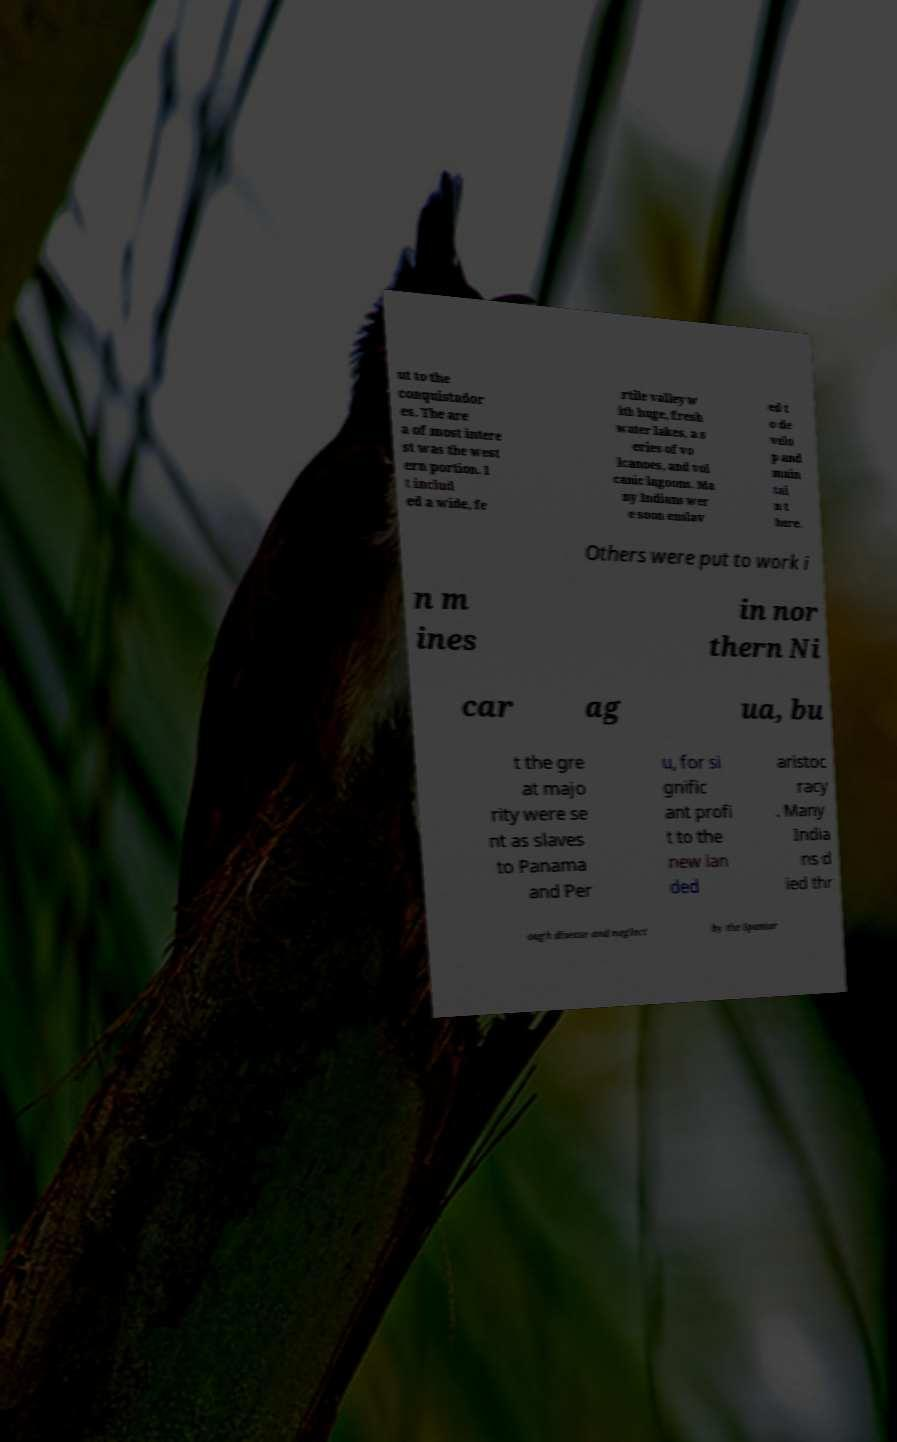Please read and relay the text visible in this image. What does it say? ut to the conquistador es. The are a of most intere st was the west ern portion. I t includ ed a wide, fe rtile valley w ith huge, fresh water lakes, a s eries of vo lcanoes, and vol canic lagoons. Ma ny Indians wer e soon enslav ed t o de velo p and main tai n t here. Others were put to work i n m ines in nor thern Ni car ag ua, bu t the gre at majo rity were se nt as slaves to Panama and Per u, for si gnific ant profi t to the new lan ded aristoc racy . Many India ns d ied thr ough disease and neglect by the Spaniar 